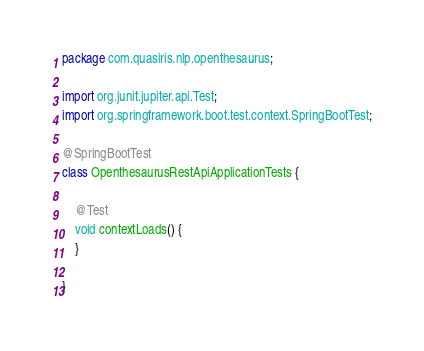<code> <loc_0><loc_0><loc_500><loc_500><_Java_>package com.quasiris.nlp.openthesaurus;

import org.junit.jupiter.api.Test;
import org.springframework.boot.test.context.SpringBootTest;

@SpringBootTest
class OpenthesaurusRestApiApplicationTests {

	@Test
	void contextLoads() {
	}

}
</code> 